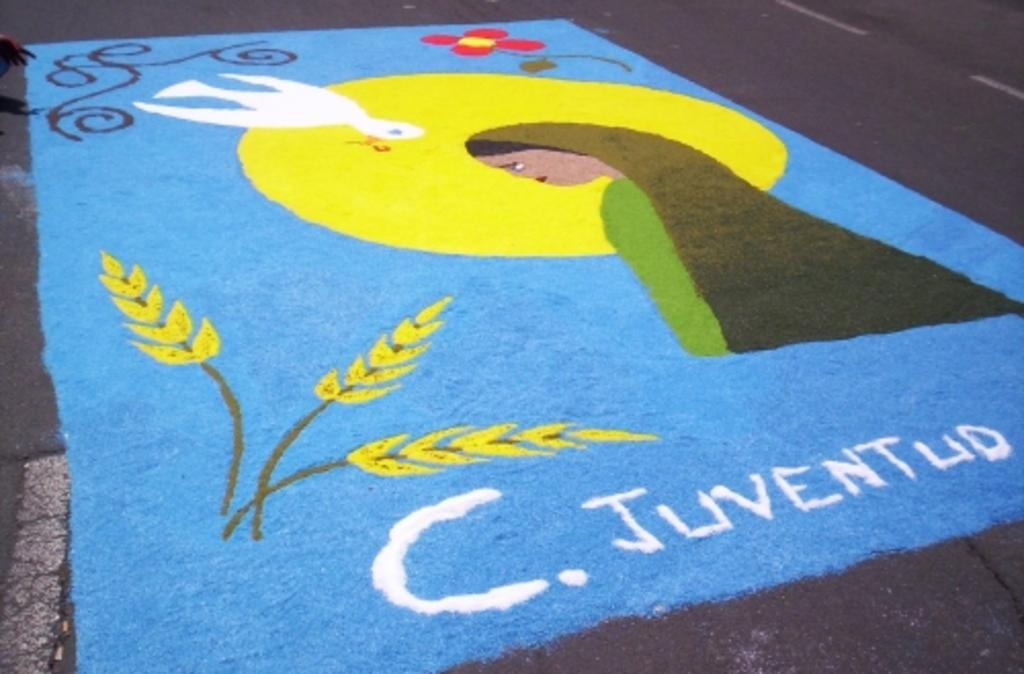What is depicted on the road in the image? There is a drawing on the road in the image. Can you describe any other elements in the image? There are hands visible on the left side of the image. What type of invention can be seen in the image? There is no invention present in the image; it only features a drawing on the road and hands on the left side. 